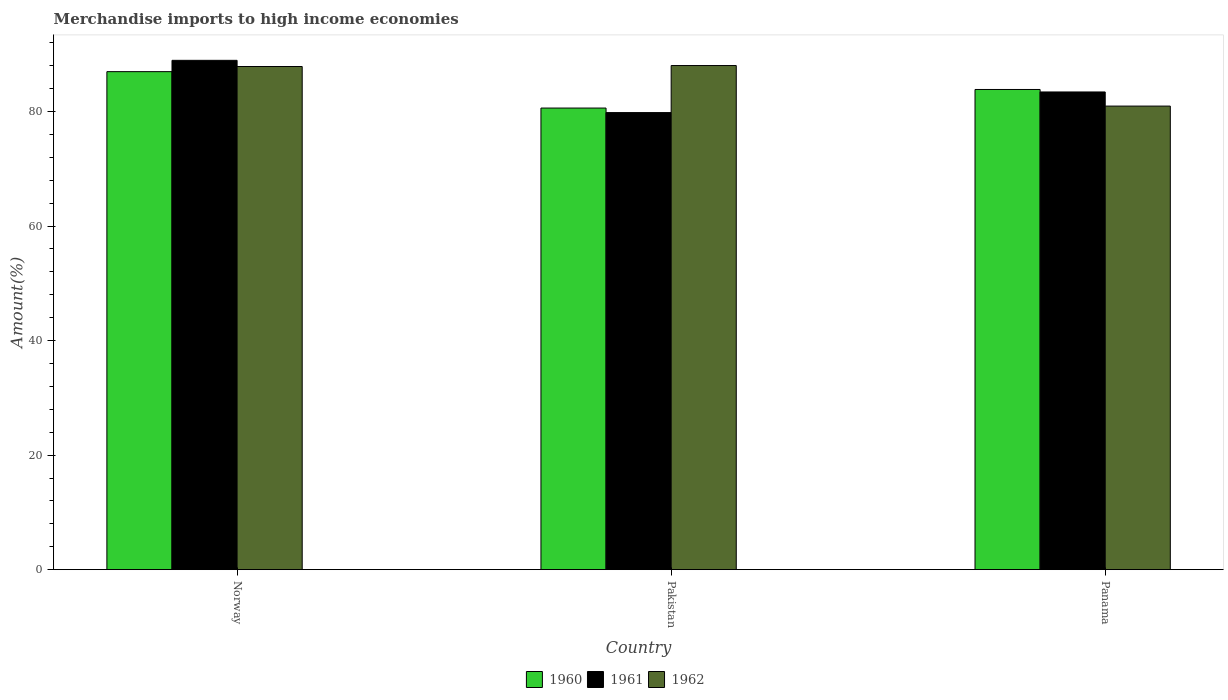How many different coloured bars are there?
Make the answer very short. 3. Are the number of bars per tick equal to the number of legend labels?
Offer a very short reply. Yes. How many bars are there on the 2nd tick from the left?
Offer a very short reply. 3. How many bars are there on the 3rd tick from the right?
Your answer should be compact. 3. What is the label of the 2nd group of bars from the left?
Your answer should be very brief. Pakistan. In how many cases, is the number of bars for a given country not equal to the number of legend labels?
Your response must be concise. 0. What is the percentage of amount earned from merchandise imports in 1961 in Panama?
Provide a succinct answer. 83.42. Across all countries, what is the maximum percentage of amount earned from merchandise imports in 1962?
Your response must be concise. 88.04. Across all countries, what is the minimum percentage of amount earned from merchandise imports in 1962?
Give a very brief answer. 80.96. In which country was the percentage of amount earned from merchandise imports in 1960 minimum?
Offer a very short reply. Pakistan. What is the total percentage of amount earned from merchandise imports in 1960 in the graph?
Your answer should be compact. 251.44. What is the difference between the percentage of amount earned from merchandise imports in 1962 in Norway and that in Panama?
Keep it short and to the point. 6.91. What is the difference between the percentage of amount earned from merchandise imports in 1962 in Norway and the percentage of amount earned from merchandise imports in 1961 in Pakistan?
Your answer should be compact. 8.05. What is the average percentage of amount earned from merchandise imports in 1960 per country?
Provide a succinct answer. 83.81. What is the difference between the percentage of amount earned from merchandise imports of/in 1962 and percentage of amount earned from merchandise imports of/in 1960 in Pakistan?
Offer a terse response. 7.43. In how many countries, is the percentage of amount earned from merchandise imports in 1961 greater than 84 %?
Give a very brief answer. 1. What is the ratio of the percentage of amount earned from merchandise imports in 1960 in Norway to that in Pakistan?
Provide a short and direct response. 1.08. Is the difference between the percentage of amount earned from merchandise imports in 1962 in Pakistan and Panama greater than the difference between the percentage of amount earned from merchandise imports in 1960 in Pakistan and Panama?
Your answer should be very brief. Yes. What is the difference between the highest and the second highest percentage of amount earned from merchandise imports in 1961?
Your answer should be very brief. 5.52. What is the difference between the highest and the lowest percentage of amount earned from merchandise imports in 1962?
Provide a short and direct response. 7.08. In how many countries, is the percentage of amount earned from merchandise imports in 1962 greater than the average percentage of amount earned from merchandise imports in 1962 taken over all countries?
Offer a very short reply. 2. Is the sum of the percentage of amount earned from merchandise imports in 1961 in Pakistan and Panama greater than the maximum percentage of amount earned from merchandise imports in 1962 across all countries?
Your response must be concise. Yes. What does the 3rd bar from the left in Panama represents?
Keep it short and to the point. 1962. Is it the case that in every country, the sum of the percentage of amount earned from merchandise imports in 1960 and percentage of amount earned from merchandise imports in 1961 is greater than the percentage of amount earned from merchandise imports in 1962?
Your answer should be very brief. Yes. How many bars are there?
Provide a succinct answer. 9. Are all the bars in the graph horizontal?
Give a very brief answer. No. Does the graph contain grids?
Offer a terse response. No. Where does the legend appear in the graph?
Offer a very short reply. Bottom center. What is the title of the graph?
Your response must be concise. Merchandise imports to high income economies. What is the label or title of the Y-axis?
Your answer should be compact. Amount(%). What is the Amount(%) of 1960 in Norway?
Give a very brief answer. 86.97. What is the Amount(%) in 1961 in Norway?
Keep it short and to the point. 88.95. What is the Amount(%) in 1962 in Norway?
Offer a terse response. 87.87. What is the Amount(%) in 1960 in Pakistan?
Offer a very short reply. 80.61. What is the Amount(%) of 1961 in Pakistan?
Offer a very short reply. 79.82. What is the Amount(%) in 1962 in Pakistan?
Your answer should be very brief. 88.04. What is the Amount(%) in 1960 in Panama?
Give a very brief answer. 83.86. What is the Amount(%) of 1961 in Panama?
Provide a succinct answer. 83.42. What is the Amount(%) of 1962 in Panama?
Keep it short and to the point. 80.96. Across all countries, what is the maximum Amount(%) of 1960?
Your response must be concise. 86.97. Across all countries, what is the maximum Amount(%) in 1961?
Your response must be concise. 88.95. Across all countries, what is the maximum Amount(%) of 1962?
Keep it short and to the point. 88.04. Across all countries, what is the minimum Amount(%) of 1960?
Offer a terse response. 80.61. Across all countries, what is the minimum Amount(%) of 1961?
Your answer should be very brief. 79.82. Across all countries, what is the minimum Amount(%) of 1962?
Your answer should be compact. 80.96. What is the total Amount(%) in 1960 in the graph?
Your response must be concise. 251.44. What is the total Amount(%) in 1961 in the graph?
Offer a terse response. 252.19. What is the total Amount(%) in 1962 in the graph?
Your answer should be compact. 256.86. What is the difference between the Amount(%) in 1960 in Norway and that in Pakistan?
Make the answer very short. 6.36. What is the difference between the Amount(%) of 1961 in Norway and that in Pakistan?
Your answer should be compact. 9.13. What is the difference between the Amount(%) of 1962 in Norway and that in Pakistan?
Make the answer very short. -0.17. What is the difference between the Amount(%) of 1960 in Norway and that in Panama?
Your response must be concise. 3.11. What is the difference between the Amount(%) in 1961 in Norway and that in Panama?
Ensure brevity in your answer.  5.52. What is the difference between the Amount(%) of 1962 in Norway and that in Panama?
Your answer should be compact. 6.91. What is the difference between the Amount(%) of 1960 in Pakistan and that in Panama?
Provide a short and direct response. -3.25. What is the difference between the Amount(%) in 1961 in Pakistan and that in Panama?
Ensure brevity in your answer.  -3.6. What is the difference between the Amount(%) of 1962 in Pakistan and that in Panama?
Ensure brevity in your answer.  7.08. What is the difference between the Amount(%) in 1960 in Norway and the Amount(%) in 1961 in Pakistan?
Keep it short and to the point. 7.15. What is the difference between the Amount(%) in 1960 in Norway and the Amount(%) in 1962 in Pakistan?
Offer a very short reply. -1.07. What is the difference between the Amount(%) in 1961 in Norway and the Amount(%) in 1962 in Pakistan?
Your answer should be very brief. 0.91. What is the difference between the Amount(%) of 1960 in Norway and the Amount(%) of 1961 in Panama?
Provide a short and direct response. 3.55. What is the difference between the Amount(%) in 1960 in Norway and the Amount(%) in 1962 in Panama?
Make the answer very short. 6.02. What is the difference between the Amount(%) of 1961 in Norway and the Amount(%) of 1962 in Panama?
Provide a short and direct response. 7.99. What is the difference between the Amount(%) in 1960 in Pakistan and the Amount(%) in 1961 in Panama?
Give a very brief answer. -2.81. What is the difference between the Amount(%) in 1960 in Pakistan and the Amount(%) in 1962 in Panama?
Ensure brevity in your answer.  -0.34. What is the difference between the Amount(%) of 1961 in Pakistan and the Amount(%) of 1962 in Panama?
Your response must be concise. -1.14. What is the average Amount(%) in 1960 per country?
Provide a succinct answer. 83.81. What is the average Amount(%) of 1961 per country?
Make the answer very short. 84.06. What is the average Amount(%) in 1962 per country?
Offer a terse response. 85.62. What is the difference between the Amount(%) in 1960 and Amount(%) in 1961 in Norway?
Make the answer very short. -1.97. What is the difference between the Amount(%) in 1960 and Amount(%) in 1962 in Norway?
Your answer should be compact. -0.9. What is the difference between the Amount(%) of 1961 and Amount(%) of 1962 in Norway?
Offer a terse response. 1.08. What is the difference between the Amount(%) in 1960 and Amount(%) in 1961 in Pakistan?
Provide a succinct answer. 0.79. What is the difference between the Amount(%) of 1960 and Amount(%) of 1962 in Pakistan?
Your answer should be very brief. -7.43. What is the difference between the Amount(%) in 1961 and Amount(%) in 1962 in Pakistan?
Your response must be concise. -8.22. What is the difference between the Amount(%) of 1960 and Amount(%) of 1961 in Panama?
Your response must be concise. 0.44. What is the difference between the Amount(%) in 1960 and Amount(%) in 1962 in Panama?
Offer a very short reply. 2.9. What is the difference between the Amount(%) in 1961 and Amount(%) in 1962 in Panama?
Offer a very short reply. 2.47. What is the ratio of the Amount(%) of 1960 in Norway to that in Pakistan?
Provide a short and direct response. 1.08. What is the ratio of the Amount(%) in 1961 in Norway to that in Pakistan?
Your response must be concise. 1.11. What is the ratio of the Amount(%) in 1962 in Norway to that in Pakistan?
Offer a very short reply. 1. What is the ratio of the Amount(%) of 1960 in Norway to that in Panama?
Offer a terse response. 1.04. What is the ratio of the Amount(%) in 1961 in Norway to that in Panama?
Your answer should be compact. 1.07. What is the ratio of the Amount(%) in 1962 in Norway to that in Panama?
Keep it short and to the point. 1.09. What is the ratio of the Amount(%) in 1960 in Pakistan to that in Panama?
Provide a succinct answer. 0.96. What is the ratio of the Amount(%) in 1961 in Pakistan to that in Panama?
Offer a terse response. 0.96. What is the ratio of the Amount(%) of 1962 in Pakistan to that in Panama?
Your answer should be very brief. 1.09. What is the difference between the highest and the second highest Amount(%) of 1960?
Your response must be concise. 3.11. What is the difference between the highest and the second highest Amount(%) in 1961?
Offer a terse response. 5.52. What is the difference between the highest and the second highest Amount(%) in 1962?
Your answer should be compact. 0.17. What is the difference between the highest and the lowest Amount(%) in 1960?
Ensure brevity in your answer.  6.36. What is the difference between the highest and the lowest Amount(%) of 1961?
Keep it short and to the point. 9.13. What is the difference between the highest and the lowest Amount(%) in 1962?
Make the answer very short. 7.08. 